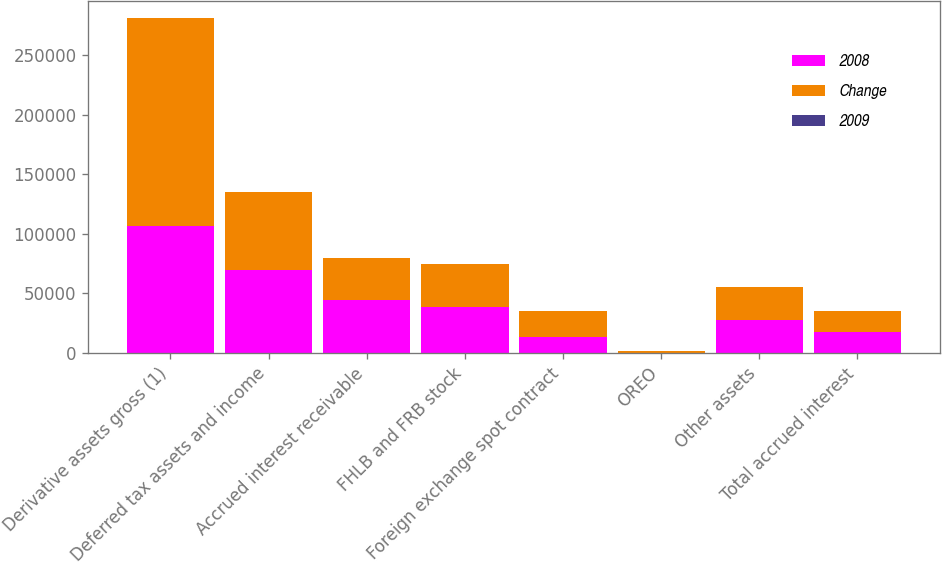Convert chart. <chart><loc_0><loc_0><loc_500><loc_500><stacked_bar_chart><ecel><fcel>Derivative assets gross (1)<fcel>Deferred tax assets and income<fcel>Accrued interest receivable<fcel>FHLB and FRB stock<fcel>Foreign exchange spot contract<fcel>OREO<fcel>Other assets<fcel>Total accrued interest<nl><fcel>2008<fcel>106623<fcel>69945<fcel>44265<fcel>38888<fcel>13653<fcel>220<fcel>27642<fcel>17493<nl><fcel>Change<fcel>174990<fcel>65372<fcel>35218<fcel>35651<fcel>21333<fcel>1250<fcel>28103<fcel>17493<nl><fcel>2009<fcel>39.1<fcel>7<fcel>25.7<fcel>9.1<fcel>36<fcel>82.4<fcel>1.6<fcel>9<nl></chart> 